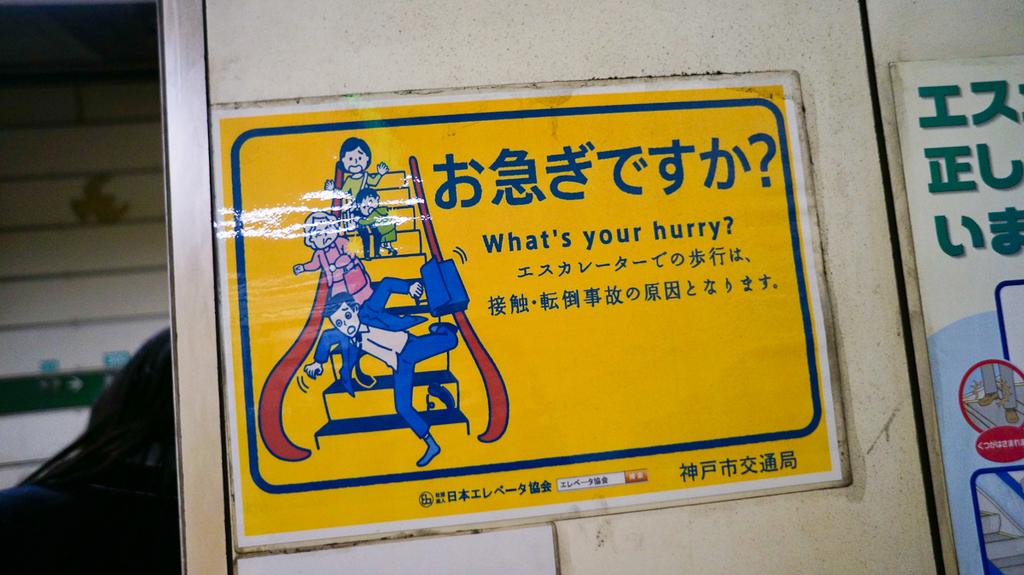What's your what?
Give a very brief answer. Hurry. What language is on the writings?
Give a very brief answer. Unanswerable. 